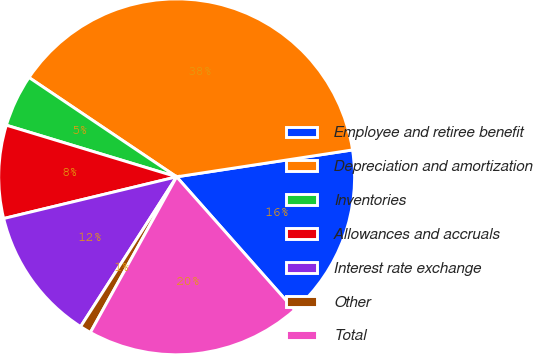<chart> <loc_0><loc_0><loc_500><loc_500><pie_chart><fcel>Employee and retiree benefit<fcel>Depreciation and amortization<fcel>Inventories<fcel>Allowances and accruals<fcel>Interest rate exchange<fcel>Other<fcel>Total<nl><fcel>15.88%<fcel>38.16%<fcel>4.74%<fcel>8.45%<fcel>12.16%<fcel>1.02%<fcel>19.59%<nl></chart> 